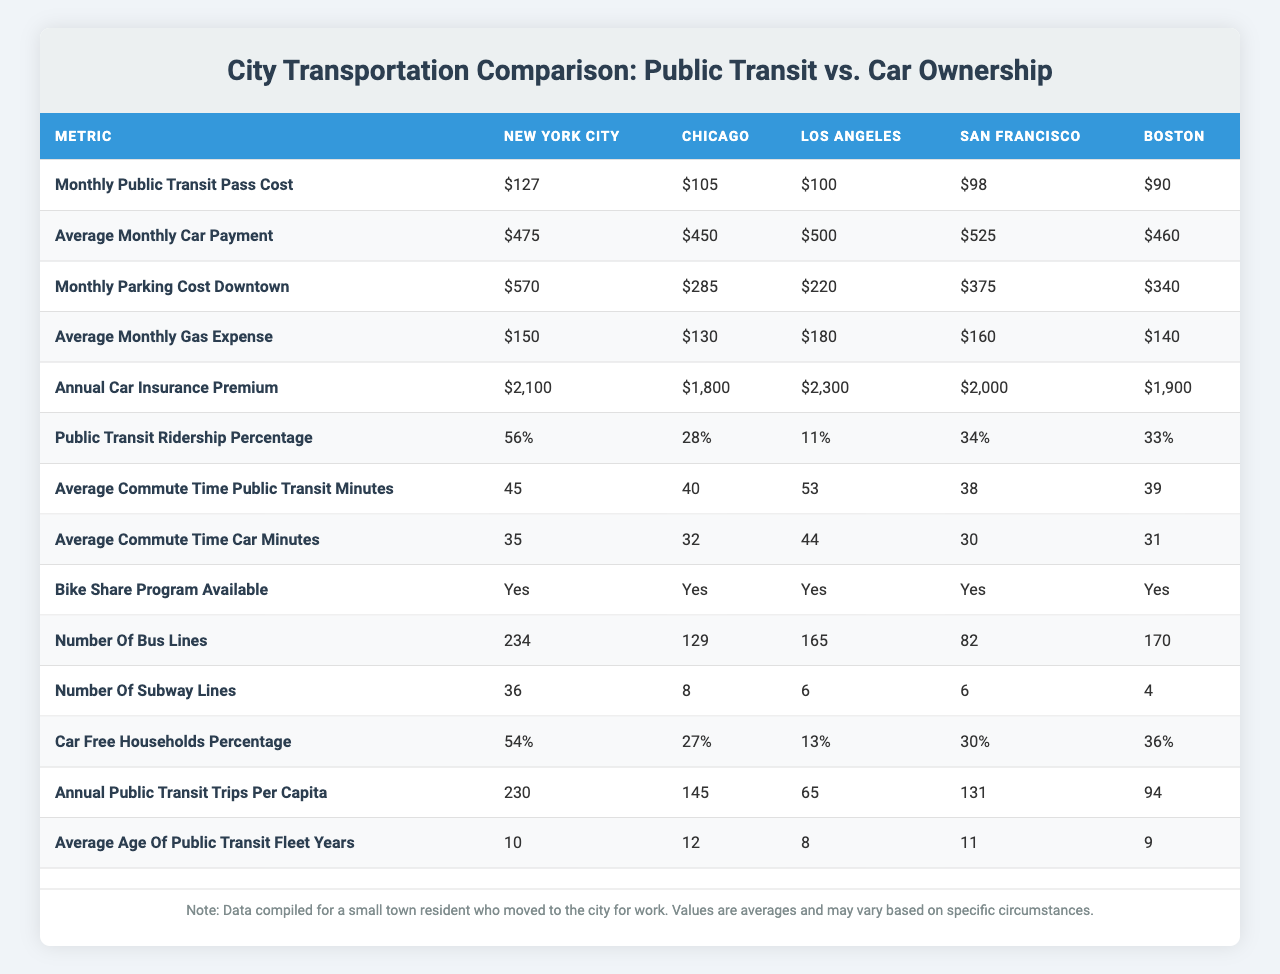What is the monthly public transit pass cost in San Francisco? The table shows the "Monthly_Public_Transit_Pass_Cost" for each city, and for San Francisco, the value is listed as $98.
Answer: $98 Which city has the highest average monthly car payment? Reviewing the "Average_Monthly_Car_Payment" column, we can see that Los Angeles has the highest value at $500.
Answer: $500 What is the difference between the average monthly parking cost downtown in New York City and Boston? We look at the "Monthly_Parking_Cost_Downtown" for New York City at $570 and for Boston at $340. The difference is $570 - $340 = $230.
Answer: $230 Is there a bike share program available in all cities listed? The "Bike_Share_Program_Available" column shows true for all cities listed, indicating that a bike share program is indeed available in each city.
Answer: Yes What is the average monthly cost of car ownership (including payments, parking costs, gas, and insurance) in Chicago? First, we sum the values for Chicago: Average Monthly Car Payment $450 + Monthly Parking Cost Downtown $285 + Average Monthly Gas Expense $130 + Annual Car Insurance Premium ($1800/12 = $150). Total is $450 + $285 + $130 + $150 = $1015.
Answer: $1015 Calculate the percentage of car-free households in Los Angeles compared to the city with the highest car-free households percentage. Los Angeles has 13% of car-free households, compared to New York City, which has 54%. To find the percentage that Los Angeles represents of New York City, we perform (13/54) * 100, which equals approximately 24.07%.
Answer: 24.07% What is the average commute time by public transit across all cities? To find this, we sum the "Average_Commute_Time_Public_Transit_Minutes": 45 + 40 + 53 + 38 + 39 = 215 minutes. Then, divide by the number of cities (5) to get the average: 215/5 = 43 minutes.
Answer: 43 minutes Which city has the highest annual public transit trips per capita? By analyzing the "Annual_Public_Transit_Trips_Per_Capita" column, we see that New York City leads with 230 trips per capita.
Answer: 230 trips How much is the total monthly cost of owning a car (including all expenses) in San Francisco? For San Francisco, we add together the average monthly car payment ($525), parking cost ($375), gas expense ($160), and divide the annual insurance premium ($2000) by 12 to get $166.67. Therefore, the total is $525 + $375 + $160 + $166.67 = $1226.67.
Answer: $1226.67 Are public transit ridership percentages correlated with car-free households percentages across the cities? Observing "Public_Transit_Ridership_Percentage" and "Car_Free_Households_Percentage," we see that New York City has the highest transit ridership (56%) and car-free households (54%), while Los Angeles has the lowest (11% and 13% respectively). This suggests a possible positive correlation, as cities with higher ridership often have more car-free households.
Answer: Yes 